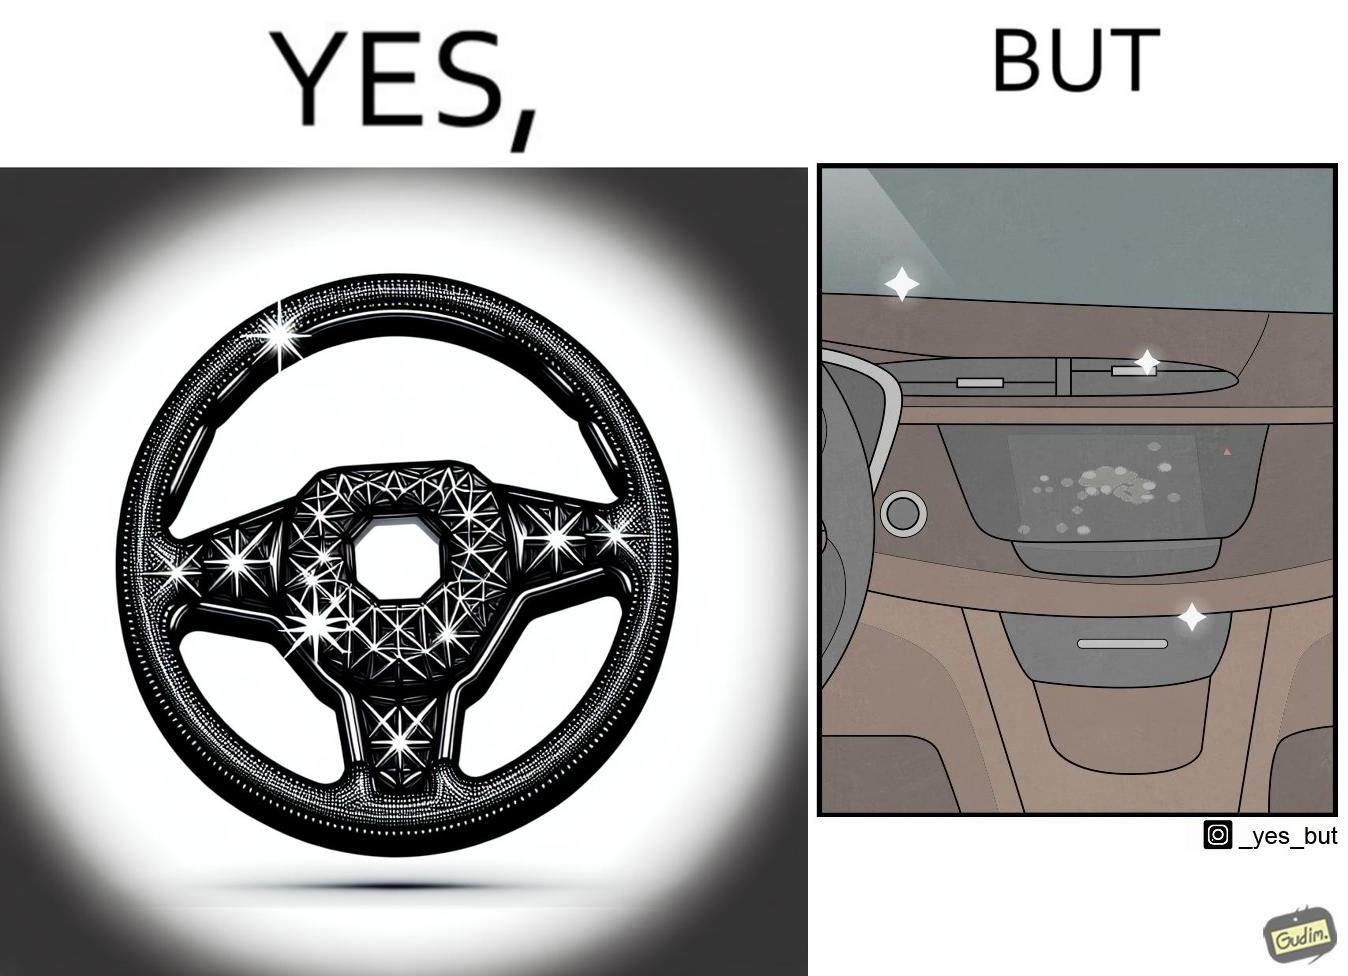Compare the left and right sides of this image. In the left part of the image: sparkling steering wheel of a car. In the right part of the image: dashboard of a car, with the touch panel full of greasy fingerprints. 